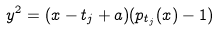Convert formula to latex. <formula><loc_0><loc_0><loc_500><loc_500>y ^ { 2 } = ( x - t _ { j } + a ) ( p _ { t _ { j } } ( x ) - 1 )</formula> 